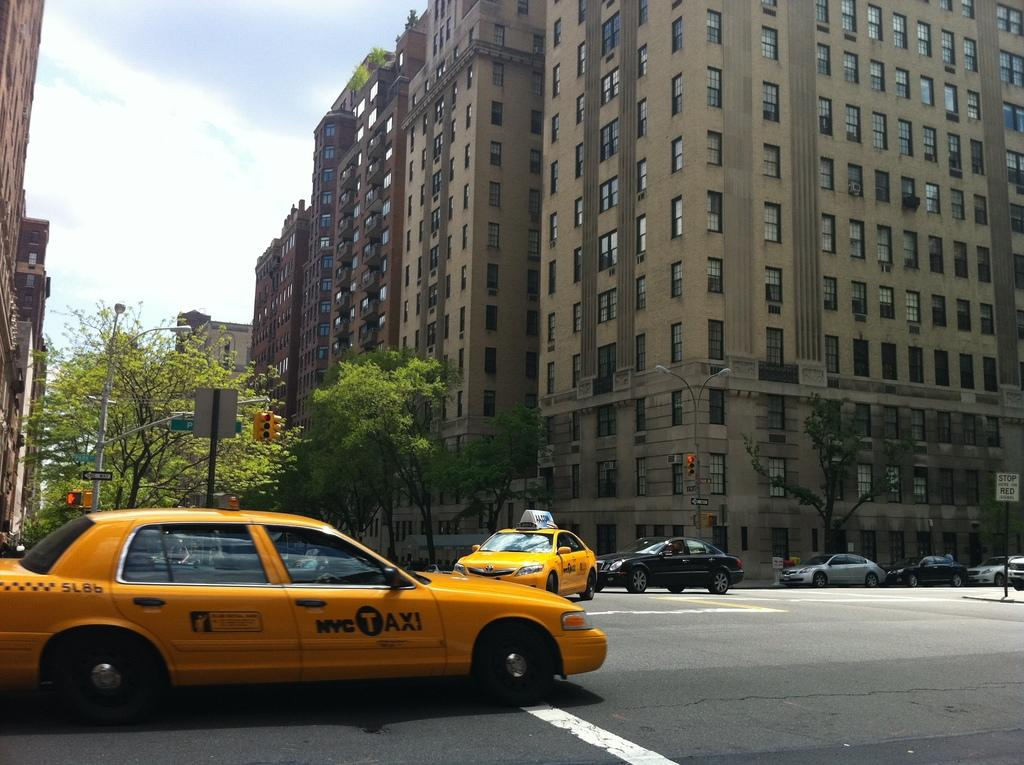<image>
Render a clear and concise summary of the photo. An NYC taxi is shown at an intersection. 